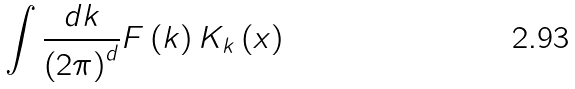<formula> <loc_0><loc_0><loc_500><loc_500>\int \frac { d k } { \left ( 2 \pi \right ) ^ { d } } F \left ( k \right ) K _ { k } \left ( x \right )</formula> 